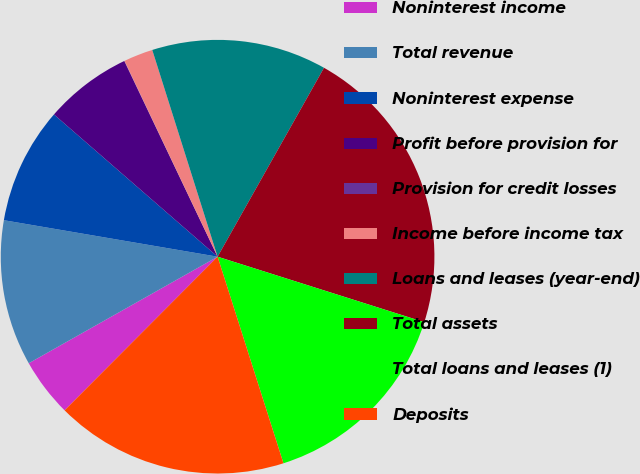<chart> <loc_0><loc_0><loc_500><loc_500><pie_chart><fcel>Noninterest income<fcel>Total revenue<fcel>Noninterest expense<fcel>Profit before provision for<fcel>Provision for credit losses<fcel>Income before income tax<fcel>Loans and leases (year-end)<fcel>Total assets<fcel>Total loans and leases (1)<fcel>Deposits<nl><fcel>4.36%<fcel>10.87%<fcel>8.7%<fcel>6.53%<fcel>0.02%<fcel>2.19%<fcel>13.04%<fcel>21.72%<fcel>15.21%<fcel>17.38%<nl></chart> 